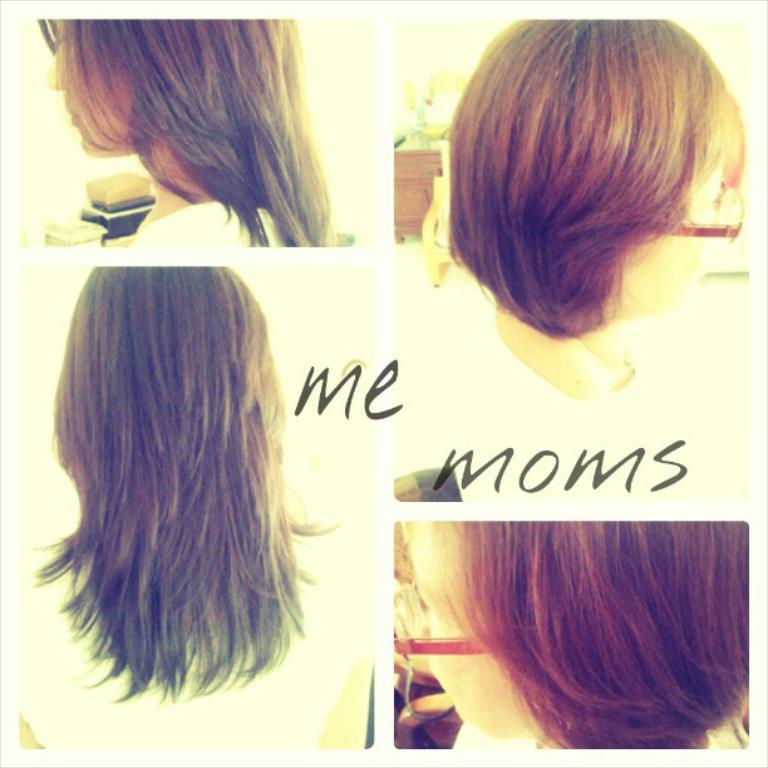What type of artwork is depicted in the image? The image is a collage. What can be seen within the collage? There are faces of people and images of hair in the collage. Are there any words or letters in the collage? Yes, there is text present in the collage. What type of lettuce is growing in the cave in the image? There is no lettuce or cave present in the image; it is a collage featuring faces of people, images of hair, and text. 